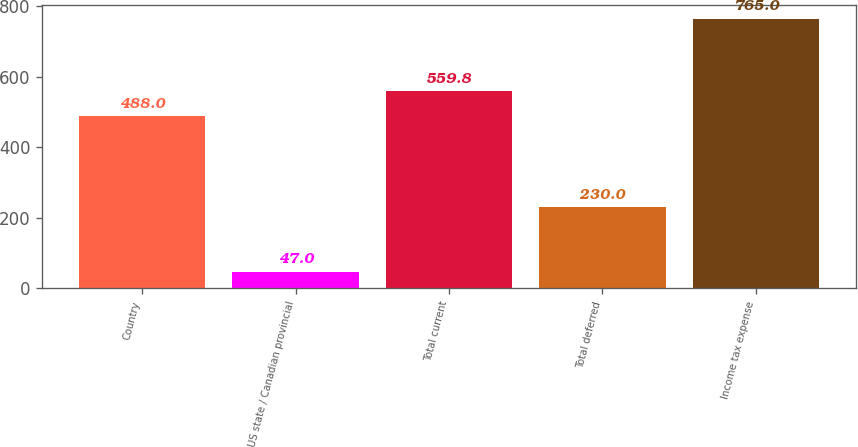<chart> <loc_0><loc_0><loc_500><loc_500><bar_chart><fcel>Country<fcel>US state / Canadian provincial<fcel>Total current<fcel>Total deferred<fcel>Income tax expense<nl><fcel>488<fcel>47<fcel>559.8<fcel>230<fcel>765<nl></chart> 